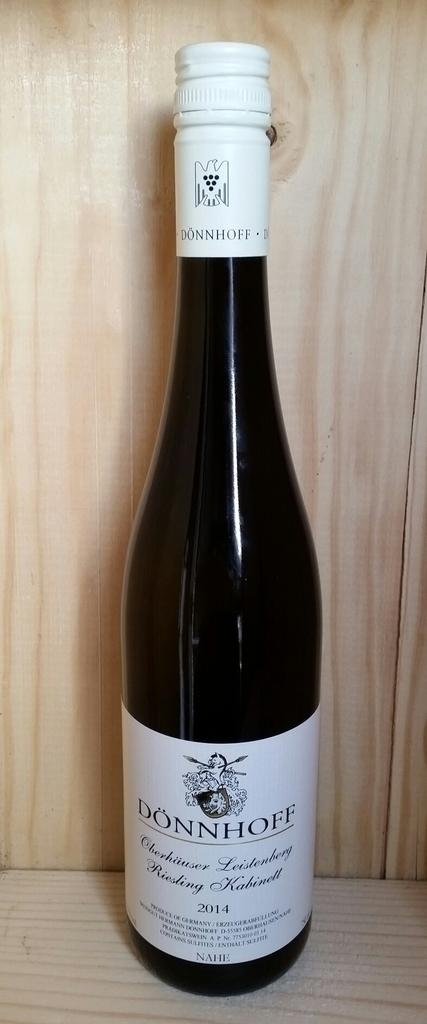<image>
Relay a brief, clear account of the picture shown. A bottle of Don Hoff alcohol is sitting on a shelf. 